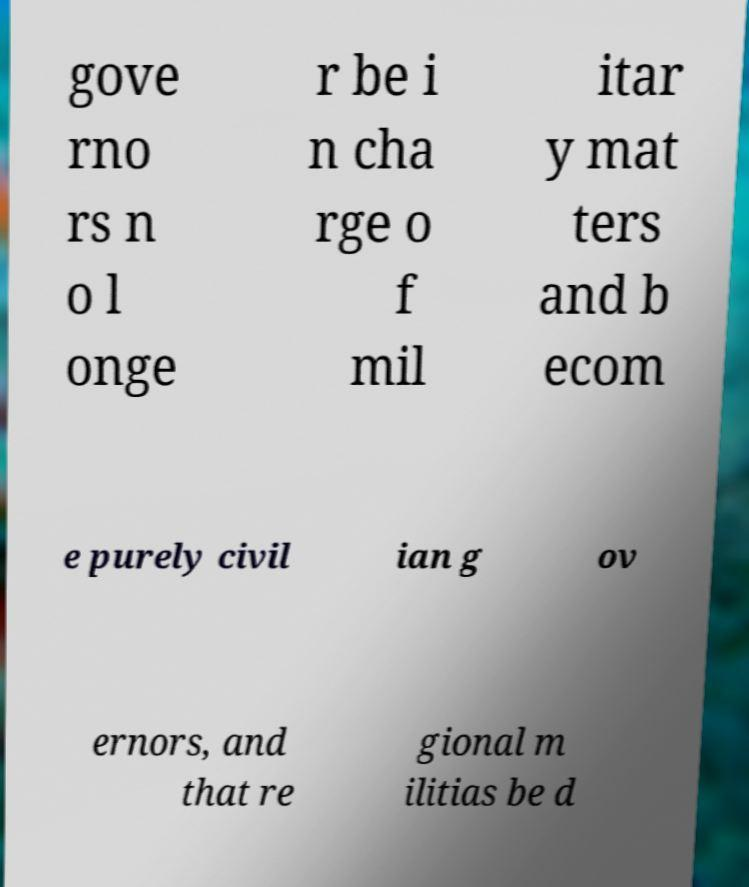There's text embedded in this image that I need extracted. Can you transcribe it verbatim? gove rno rs n o l onge r be i n cha rge o f mil itar y mat ters and b ecom e purely civil ian g ov ernors, and that re gional m ilitias be d 